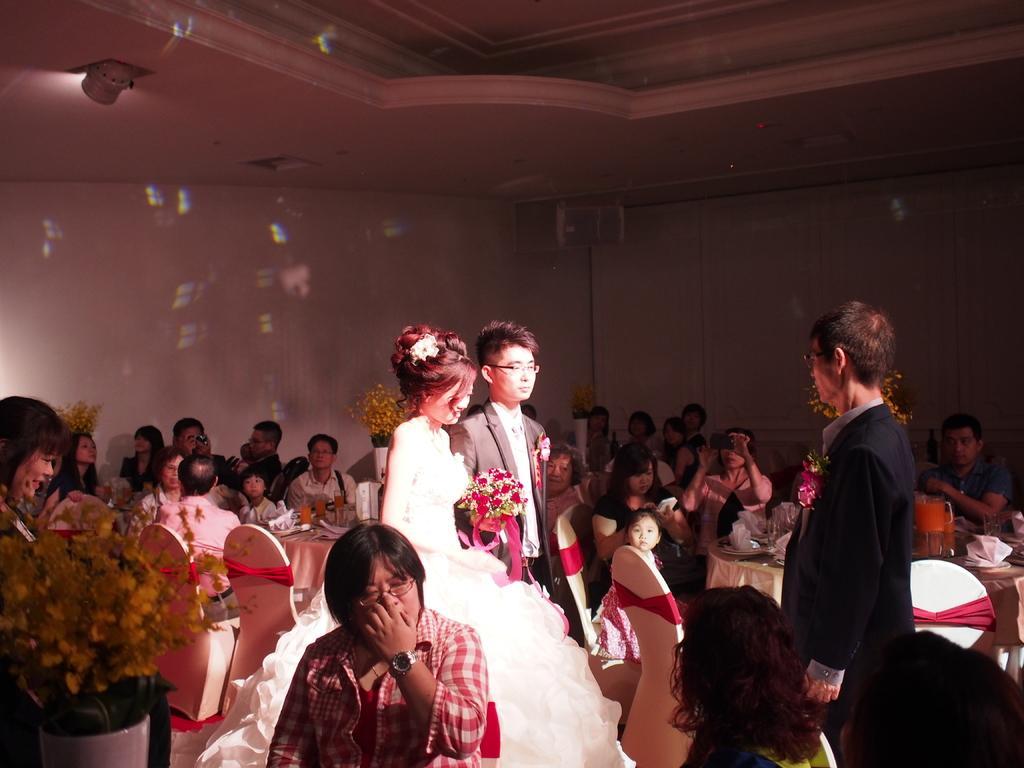How would you summarize this image in a sentence or two? In this picture there is a girl who is wearing white dress and holding flowers. Beside her we can see a man who is wearing suits, trouser and spectacle. Both of them are standing near to the tables. Here we can see group of person sitting on the chair and they are taking photos from the mobile phone. On the bottom there is a man who is sitting on the chair. At the top we can see lights. 